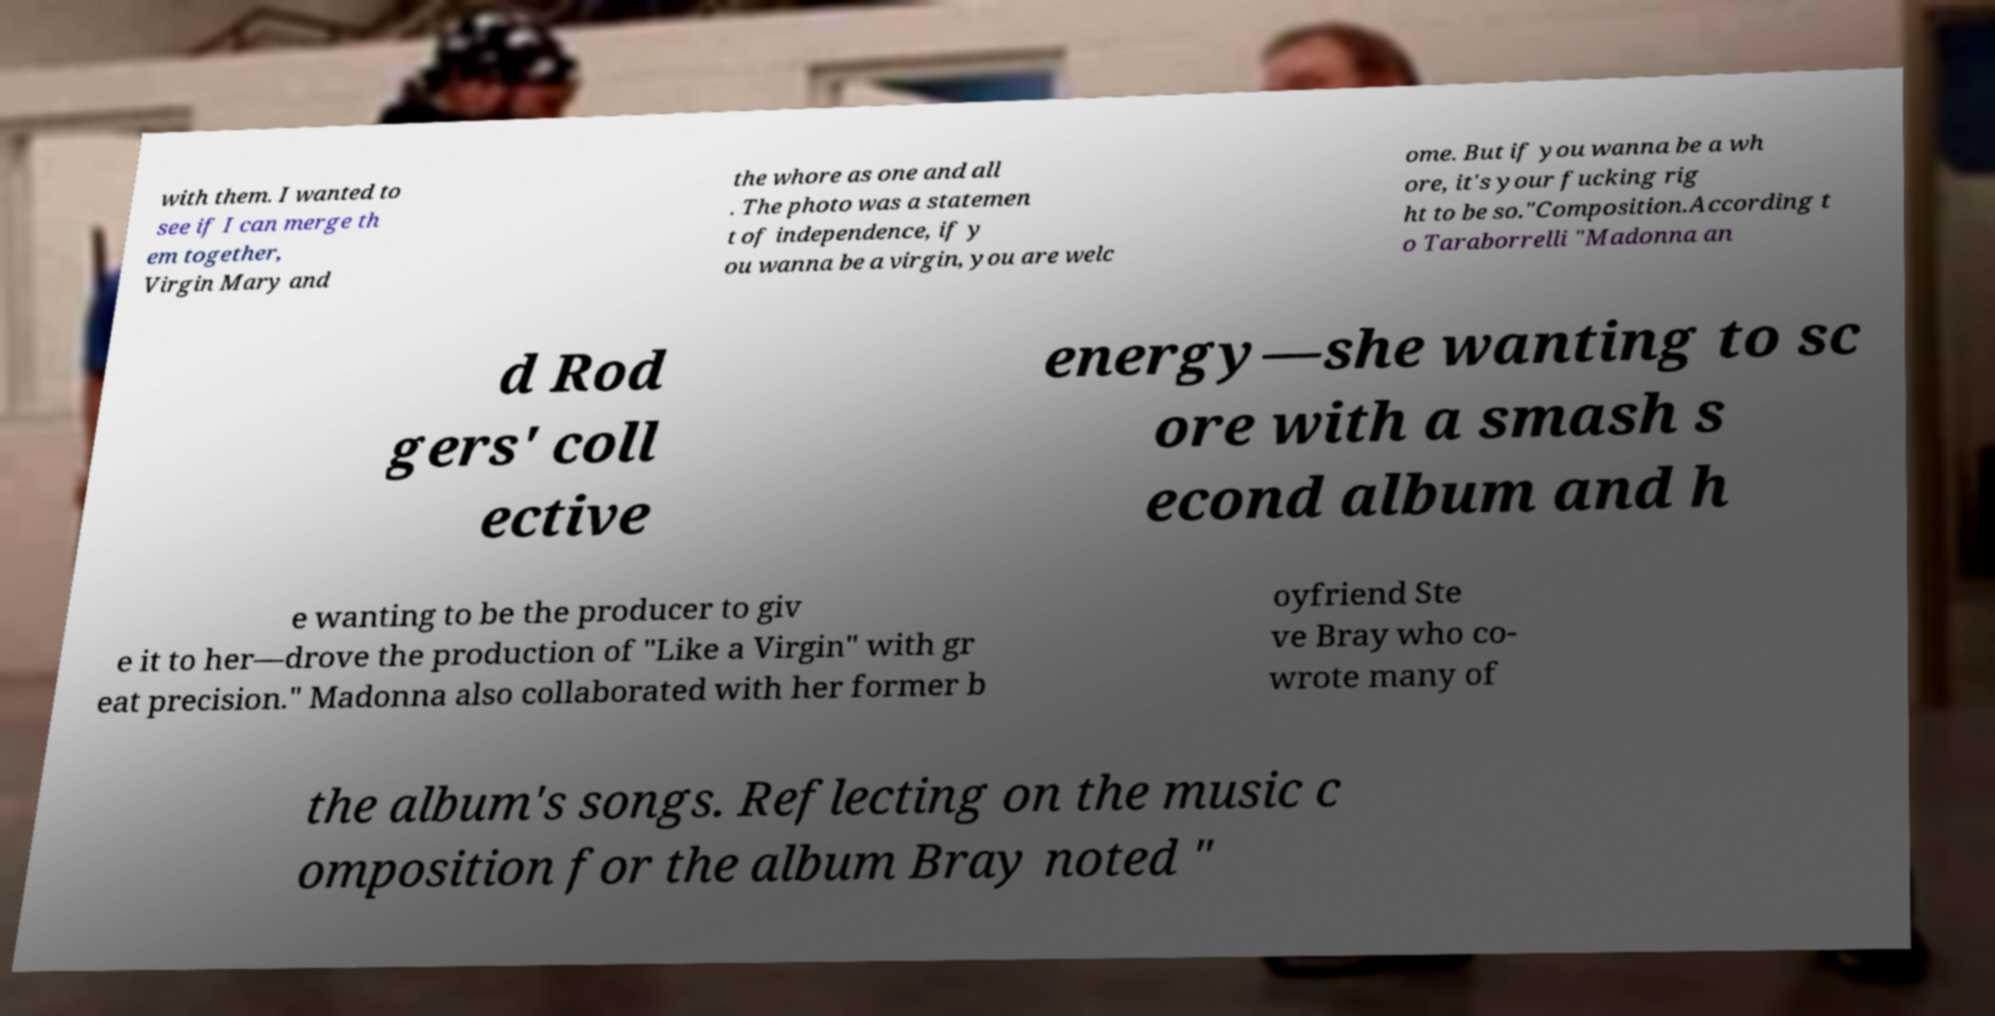Can you read and provide the text displayed in the image?This photo seems to have some interesting text. Can you extract and type it out for me? with them. I wanted to see if I can merge th em together, Virgin Mary and the whore as one and all . The photo was a statemen t of independence, if y ou wanna be a virgin, you are welc ome. But if you wanna be a wh ore, it's your fucking rig ht to be so."Composition.According t o Taraborrelli "Madonna an d Rod gers' coll ective energy—she wanting to sc ore with a smash s econd album and h e wanting to be the producer to giv e it to her—drove the production of "Like a Virgin" with gr eat precision." Madonna also collaborated with her former b oyfriend Ste ve Bray who co- wrote many of the album's songs. Reflecting on the music c omposition for the album Bray noted " 